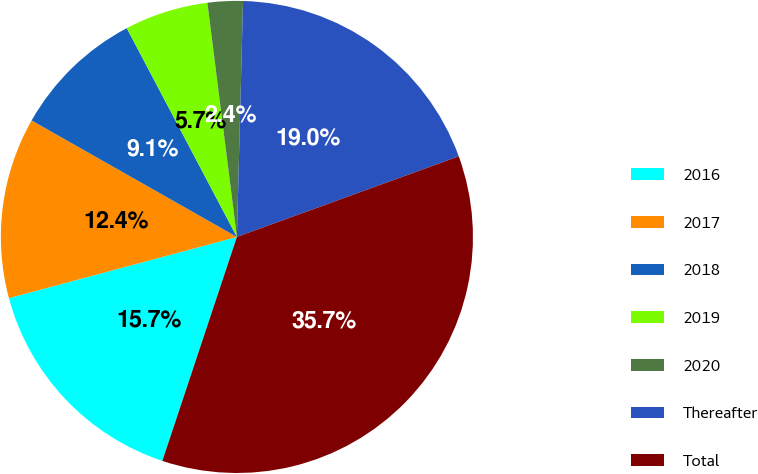<chart> <loc_0><loc_0><loc_500><loc_500><pie_chart><fcel>2016<fcel>2017<fcel>2018<fcel>2019<fcel>2020<fcel>Thereafter<fcel>Total<nl><fcel>15.71%<fcel>12.39%<fcel>9.06%<fcel>5.73%<fcel>2.41%<fcel>19.04%<fcel>35.66%<nl></chart> 